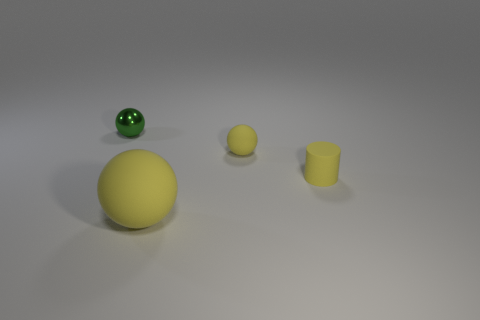Add 4 small matte cubes. How many objects exist? 8 Subtract 0 gray cylinders. How many objects are left? 4 Subtract all cylinders. How many objects are left? 3 Subtract all tiny yellow things. Subtract all metal objects. How many objects are left? 1 Add 1 tiny green shiny things. How many tiny green shiny things are left? 2 Add 1 small cylinders. How many small cylinders exist? 2 